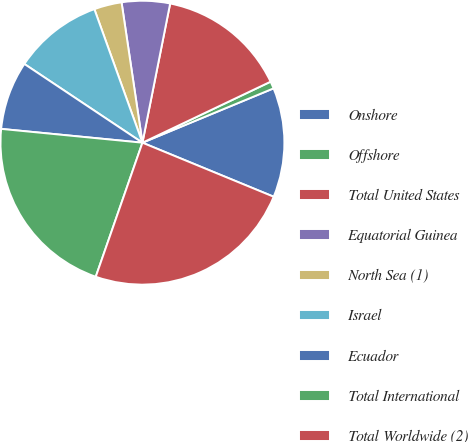Convert chart to OTSL. <chart><loc_0><loc_0><loc_500><loc_500><pie_chart><fcel>Onshore<fcel>Offshore<fcel>Total United States<fcel>Equatorial Guinea<fcel>North Sea (1)<fcel>Israel<fcel>Ecuador<fcel>Total International<fcel>Total Worldwide (2)<nl><fcel>12.47%<fcel>0.82%<fcel>14.8%<fcel>5.48%<fcel>3.15%<fcel>10.14%<fcel>7.81%<fcel>21.22%<fcel>24.12%<nl></chart> 